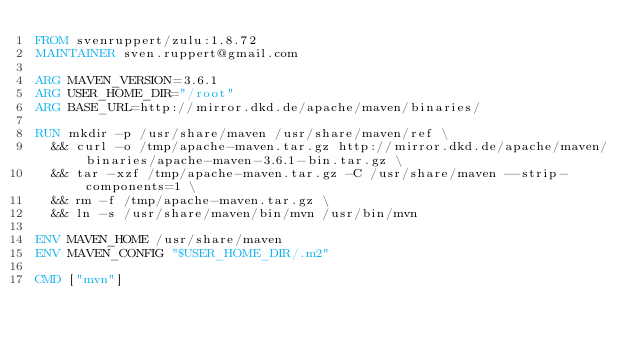Convert code to text. <code><loc_0><loc_0><loc_500><loc_500><_Dockerfile_>FROM svenruppert/zulu:1.8.72
MAINTAINER sven.ruppert@gmail.com

ARG MAVEN_VERSION=3.6.1
ARG USER_HOME_DIR="/root"
ARG BASE_URL=http://mirror.dkd.de/apache/maven/binaries/

RUN mkdir -p /usr/share/maven /usr/share/maven/ref \
  && curl -o /tmp/apache-maven.tar.gz http://mirror.dkd.de/apache/maven/binaries/apache-maven-3.6.1-bin.tar.gz \
  && tar -xzf /tmp/apache-maven.tar.gz -C /usr/share/maven --strip-components=1 \
  && rm -f /tmp/apache-maven.tar.gz \
  && ln -s /usr/share/maven/bin/mvn /usr/bin/mvn

ENV MAVEN_HOME /usr/share/maven
ENV MAVEN_CONFIG "$USER_HOME_DIR/.m2"

CMD ["mvn"]</code> 